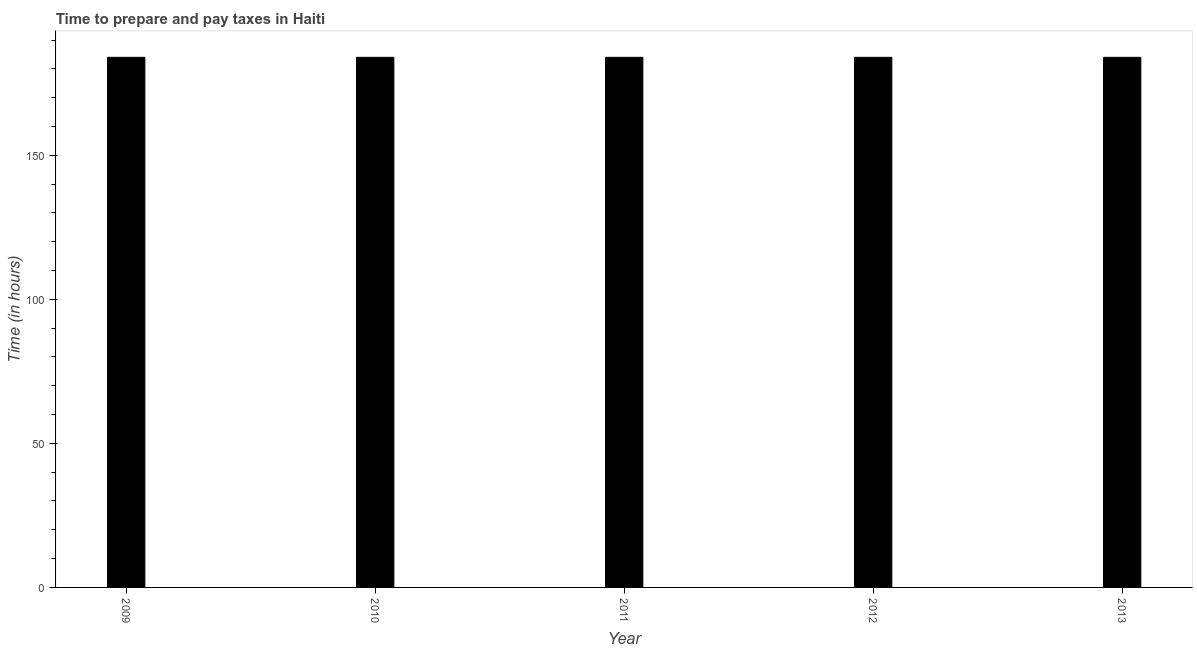What is the title of the graph?
Keep it short and to the point. Time to prepare and pay taxes in Haiti. What is the label or title of the X-axis?
Keep it short and to the point. Year. What is the label or title of the Y-axis?
Offer a very short reply. Time (in hours). What is the time to prepare and pay taxes in 2011?
Make the answer very short. 184. Across all years, what is the maximum time to prepare and pay taxes?
Offer a very short reply. 184. Across all years, what is the minimum time to prepare and pay taxes?
Your response must be concise. 184. In which year was the time to prepare and pay taxes minimum?
Offer a very short reply. 2009. What is the sum of the time to prepare and pay taxes?
Ensure brevity in your answer.  920. What is the difference between the time to prepare and pay taxes in 2011 and 2012?
Your response must be concise. 0. What is the average time to prepare and pay taxes per year?
Offer a terse response. 184. What is the median time to prepare and pay taxes?
Keep it short and to the point. 184. Do a majority of the years between 2011 and 2010 (inclusive) have time to prepare and pay taxes greater than 20 hours?
Keep it short and to the point. No. What is the difference between the highest and the second highest time to prepare and pay taxes?
Offer a terse response. 0. Is the sum of the time to prepare and pay taxes in 2009 and 2012 greater than the maximum time to prepare and pay taxes across all years?
Your answer should be compact. Yes. In how many years, is the time to prepare and pay taxes greater than the average time to prepare and pay taxes taken over all years?
Make the answer very short. 0. How many bars are there?
Your answer should be compact. 5. Are all the bars in the graph horizontal?
Make the answer very short. No. Are the values on the major ticks of Y-axis written in scientific E-notation?
Offer a terse response. No. What is the Time (in hours) of 2009?
Keep it short and to the point. 184. What is the Time (in hours) in 2010?
Provide a succinct answer. 184. What is the Time (in hours) in 2011?
Make the answer very short. 184. What is the Time (in hours) of 2012?
Ensure brevity in your answer.  184. What is the Time (in hours) of 2013?
Keep it short and to the point. 184. What is the difference between the Time (in hours) in 2009 and 2010?
Provide a succinct answer. 0. What is the difference between the Time (in hours) in 2009 and 2013?
Your response must be concise. 0. What is the difference between the Time (in hours) in 2010 and 2012?
Keep it short and to the point. 0. What is the difference between the Time (in hours) in 2011 and 2012?
Offer a very short reply. 0. What is the ratio of the Time (in hours) in 2009 to that in 2010?
Your answer should be very brief. 1. What is the ratio of the Time (in hours) in 2009 to that in 2011?
Make the answer very short. 1. What is the ratio of the Time (in hours) in 2009 to that in 2012?
Keep it short and to the point. 1. What is the ratio of the Time (in hours) in 2009 to that in 2013?
Provide a succinct answer. 1. What is the ratio of the Time (in hours) in 2010 to that in 2011?
Offer a terse response. 1. What is the ratio of the Time (in hours) in 2010 to that in 2012?
Your answer should be compact. 1. What is the ratio of the Time (in hours) in 2010 to that in 2013?
Offer a very short reply. 1. What is the ratio of the Time (in hours) in 2011 to that in 2013?
Offer a very short reply. 1. What is the ratio of the Time (in hours) in 2012 to that in 2013?
Your answer should be compact. 1. 